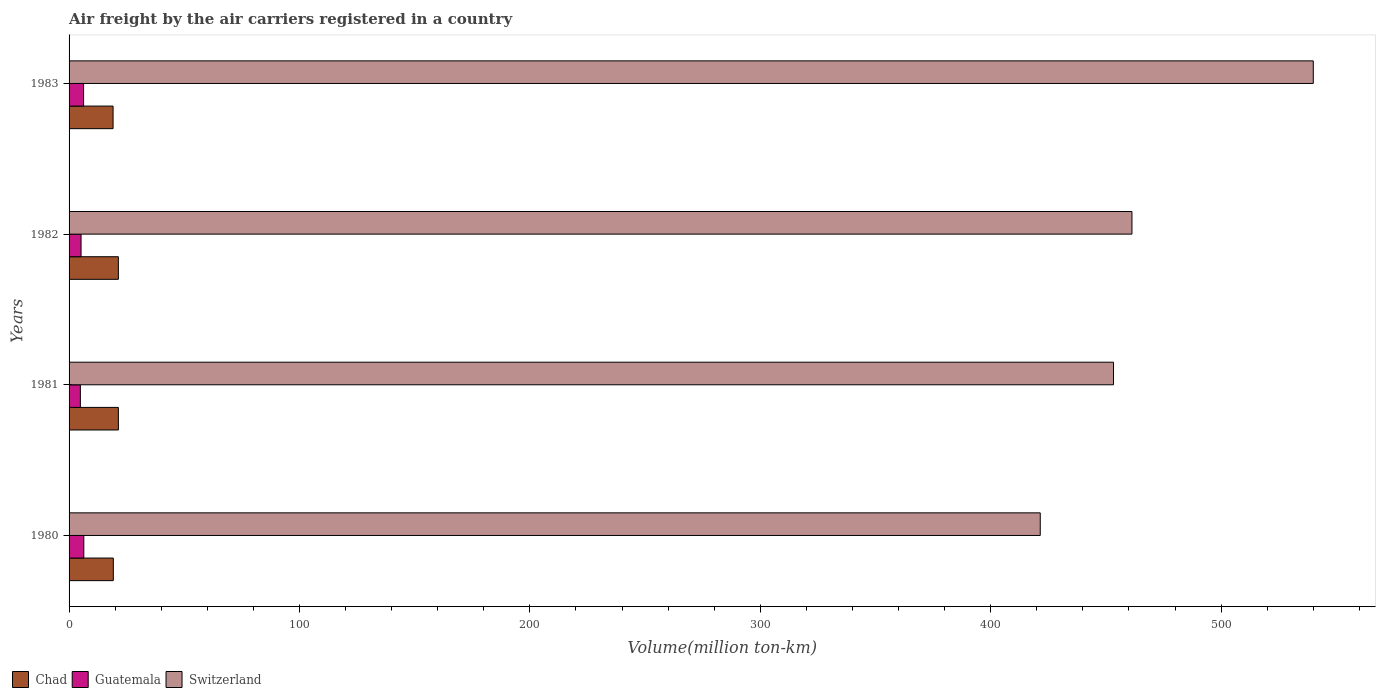How many different coloured bars are there?
Your response must be concise. 3. How many groups of bars are there?
Provide a succinct answer. 4. Are the number of bars per tick equal to the number of legend labels?
Ensure brevity in your answer.  Yes. Are the number of bars on each tick of the Y-axis equal?
Offer a terse response. Yes. How many bars are there on the 1st tick from the bottom?
Provide a short and direct response. 3. What is the volume of the air carriers in Switzerland in 1983?
Keep it short and to the point. 540. Across all years, what is the maximum volume of the air carriers in Chad?
Offer a very short reply. 21.4. Across all years, what is the minimum volume of the air carriers in Guatemala?
Give a very brief answer. 4.9. In which year was the volume of the air carriers in Switzerland maximum?
Provide a short and direct response. 1983. In which year was the volume of the air carriers in Switzerland minimum?
Your answer should be very brief. 1980. What is the total volume of the air carriers in Switzerland in the graph?
Provide a succinct answer. 1876.1. What is the difference between the volume of the air carriers in Chad in 1980 and that in 1982?
Your answer should be very brief. -2.2. What is the difference between the volume of the air carriers in Switzerland in 1981 and the volume of the air carriers in Guatemala in 1983?
Offer a very short reply. 447. What is the average volume of the air carriers in Guatemala per year?
Keep it short and to the point. 5.7. In the year 1981, what is the difference between the volume of the air carriers in Chad and volume of the air carriers in Switzerland?
Ensure brevity in your answer.  -431.9. What is the ratio of the volume of the air carriers in Chad in 1982 to that in 1983?
Make the answer very short. 1.12. Is the difference between the volume of the air carriers in Chad in 1980 and 1982 greater than the difference between the volume of the air carriers in Switzerland in 1980 and 1982?
Keep it short and to the point. Yes. What is the difference between the highest and the lowest volume of the air carriers in Chad?
Your answer should be very brief. 2.3. In how many years, is the volume of the air carriers in Guatemala greater than the average volume of the air carriers in Guatemala taken over all years?
Give a very brief answer. 2. What does the 1st bar from the top in 1981 represents?
Provide a short and direct response. Switzerland. What does the 2nd bar from the bottom in 1980 represents?
Keep it short and to the point. Guatemala. How many bars are there?
Provide a short and direct response. 12. Are the values on the major ticks of X-axis written in scientific E-notation?
Your answer should be compact. No. Does the graph contain any zero values?
Ensure brevity in your answer.  No. Where does the legend appear in the graph?
Provide a succinct answer. Bottom left. What is the title of the graph?
Give a very brief answer. Air freight by the air carriers registered in a country. Does "Libya" appear as one of the legend labels in the graph?
Provide a short and direct response. No. What is the label or title of the X-axis?
Provide a succinct answer. Volume(million ton-km). What is the label or title of the Y-axis?
Give a very brief answer. Years. What is the Volume(million ton-km) of Chad in 1980?
Your response must be concise. 19.2. What is the Volume(million ton-km) of Guatemala in 1980?
Keep it short and to the point. 6.4. What is the Volume(million ton-km) of Switzerland in 1980?
Offer a terse response. 421.5. What is the Volume(million ton-km) in Chad in 1981?
Your response must be concise. 21.4. What is the Volume(million ton-km) in Guatemala in 1981?
Your answer should be compact. 4.9. What is the Volume(million ton-km) of Switzerland in 1981?
Provide a succinct answer. 453.3. What is the Volume(million ton-km) in Chad in 1982?
Provide a short and direct response. 21.4. What is the Volume(million ton-km) of Guatemala in 1982?
Keep it short and to the point. 5.2. What is the Volume(million ton-km) of Switzerland in 1982?
Keep it short and to the point. 461.3. What is the Volume(million ton-km) in Chad in 1983?
Keep it short and to the point. 19.1. What is the Volume(million ton-km) in Guatemala in 1983?
Ensure brevity in your answer.  6.3. What is the Volume(million ton-km) of Switzerland in 1983?
Provide a succinct answer. 540. Across all years, what is the maximum Volume(million ton-km) of Chad?
Ensure brevity in your answer.  21.4. Across all years, what is the maximum Volume(million ton-km) of Guatemala?
Your response must be concise. 6.4. Across all years, what is the maximum Volume(million ton-km) of Switzerland?
Your answer should be very brief. 540. Across all years, what is the minimum Volume(million ton-km) of Chad?
Offer a terse response. 19.1. Across all years, what is the minimum Volume(million ton-km) of Guatemala?
Keep it short and to the point. 4.9. Across all years, what is the minimum Volume(million ton-km) of Switzerland?
Offer a terse response. 421.5. What is the total Volume(million ton-km) of Chad in the graph?
Make the answer very short. 81.1. What is the total Volume(million ton-km) in Guatemala in the graph?
Your answer should be very brief. 22.8. What is the total Volume(million ton-km) in Switzerland in the graph?
Make the answer very short. 1876.1. What is the difference between the Volume(million ton-km) of Guatemala in 1980 and that in 1981?
Offer a terse response. 1.5. What is the difference between the Volume(million ton-km) of Switzerland in 1980 and that in 1981?
Keep it short and to the point. -31.8. What is the difference between the Volume(million ton-km) in Chad in 1980 and that in 1982?
Provide a succinct answer. -2.2. What is the difference between the Volume(million ton-km) in Guatemala in 1980 and that in 1982?
Make the answer very short. 1.2. What is the difference between the Volume(million ton-km) in Switzerland in 1980 and that in 1982?
Provide a succinct answer. -39.8. What is the difference between the Volume(million ton-km) in Guatemala in 1980 and that in 1983?
Offer a terse response. 0.1. What is the difference between the Volume(million ton-km) of Switzerland in 1980 and that in 1983?
Offer a terse response. -118.5. What is the difference between the Volume(million ton-km) of Chad in 1981 and that in 1982?
Your response must be concise. 0. What is the difference between the Volume(million ton-km) in Guatemala in 1981 and that in 1982?
Your response must be concise. -0.3. What is the difference between the Volume(million ton-km) of Switzerland in 1981 and that in 1982?
Give a very brief answer. -8. What is the difference between the Volume(million ton-km) in Chad in 1981 and that in 1983?
Offer a very short reply. 2.3. What is the difference between the Volume(million ton-km) in Guatemala in 1981 and that in 1983?
Keep it short and to the point. -1.4. What is the difference between the Volume(million ton-km) of Switzerland in 1981 and that in 1983?
Your answer should be compact. -86.7. What is the difference between the Volume(million ton-km) in Switzerland in 1982 and that in 1983?
Give a very brief answer. -78.7. What is the difference between the Volume(million ton-km) of Chad in 1980 and the Volume(million ton-km) of Switzerland in 1981?
Make the answer very short. -434.1. What is the difference between the Volume(million ton-km) of Guatemala in 1980 and the Volume(million ton-km) of Switzerland in 1981?
Provide a short and direct response. -446.9. What is the difference between the Volume(million ton-km) in Chad in 1980 and the Volume(million ton-km) in Switzerland in 1982?
Offer a terse response. -442.1. What is the difference between the Volume(million ton-km) in Guatemala in 1980 and the Volume(million ton-km) in Switzerland in 1982?
Your response must be concise. -454.9. What is the difference between the Volume(million ton-km) in Chad in 1980 and the Volume(million ton-km) in Switzerland in 1983?
Give a very brief answer. -520.8. What is the difference between the Volume(million ton-km) in Guatemala in 1980 and the Volume(million ton-km) in Switzerland in 1983?
Offer a very short reply. -533.6. What is the difference between the Volume(million ton-km) of Chad in 1981 and the Volume(million ton-km) of Switzerland in 1982?
Make the answer very short. -439.9. What is the difference between the Volume(million ton-km) in Guatemala in 1981 and the Volume(million ton-km) in Switzerland in 1982?
Ensure brevity in your answer.  -456.4. What is the difference between the Volume(million ton-km) in Chad in 1981 and the Volume(million ton-km) in Guatemala in 1983?
Make the answer very short. 15.1. What is the difference between the Volume(million ton-km) of Chad in 1981 and the Volume(million ton-km) of Switzerland in 1983?
Your answer should be compact. -518.6. What is the difference between the Volume(million ton-km) of Guatemala in 1981 and the Volume(million ton-km) of Switzerland in 1983?
Your response must be concise. -535.1. What is the difference between the Volume(million ton-km) of Chad in 1982 and the Volume(million ton-km) of Guatemala in 1983?
Provide a short and direct response. 15.1. What is the difference between the Volume(million ton-km) in Chad in 1982 and the Volume(million ton-km) in Switzerland in 1983?
Your answer should be compact. -518.6. What is the difference between the Volume(million ton-km) in Guatemala in 1982 and the Volume(million ton-km) in Switzerland in 1983?
Provide a short and direct response. -534.8. What is the average Volume(million ton-km) in Chad per year?
Offer a terse response. 20.27. What is the average Volume(million ton-km) of Guatemala per year?
Offer a very short reply. 5.7. What is the average Volume(million ton-km) in Switzerland per year?
Make the answer very short. 469.02. In the year 1980, what is the difference between the Volume(million ton-km) of Chad and Volume(million ton-km) of Guatemala?
Your response must be concise. 12.8. In the year 1980, what is the difference between the Volume(million ton-km) in Chad and Volume(million ton-km) in Switzerland?
Your response must be concise. -402.3. In the year 1980, what is the difference between the Volume(million ton-km) of Guatemala and Volume(million ton-km) of Switzerland?
Provide a succinct answer. -415.1. In the year 1981, what is the difference between the Volume(million ton-km) of Chad and Volume(million ton-km) of Guatemala?
Ensure brevity in your answer.  16.5. In the year 1981, what is the difference between the Volume(million ton-km) in Chad and Volume(million ton-km) in Switzerland?
Make the answer very short. -431.9. In the year 1981, what is the difference between the Volume(million ton-km) in Guatemala and Volume(million ton-km) in Switzerland?
Offer a terse response. -448.4. In the year 1982, what is the difference between the Volume(million ton-km) in Chad and Volume(million ton-km) in Switzerland?
Offer a terse response. -439.9. In the year 1982, what is the difference between the Volume(million ton-km) in Guatemala and Volume(million ton-km) in Switzerland?
Keep it short and to the point. -456.1. In the year 1983, what is the difference between the Volume(million ton-km) in Chad and Volume(million ton-km) in Switzerland?
Provide a short and direct response. -520.9. In the year 1983, what is the difference between the Volume(million ton-km) in Guatemala and Volume(million ton-km) in Switzerland?
Your response must be concise. -533.7. What is the ratio of the Volume(million ton-km) in Chad in 1980 to that in 1981?
Make the answer very short. 0.9. What is the ratio of the Volume(million ton-km) of Guatemala in 1980 to that in 1981?
Your answer should be compact. 1.31. What is the ratio of the Volume(million ton-km) of Switzerland in 1980 to that in 1981?
Provide a short and direct response. 0.93. What is the ratio of the Volume(million ton-km) of Chad in 1980 to that in 1982?
Offer a terse response. 0.9. What is the ratio of the Volume(million ton-km) in Guatemala in 1980 to that in 1982?
Make the answer very short. 1.23. What is the ratio of the Volume(million ton-km) in Switzerland in 1980 to that in 1982?
Your answer should be very brief. 0.91. What is the ratio of the Volume(million ton-km) of Guatemala in 1980 to that in 1983?
Keep it short and to the point. 1.02. What is the ratio of the Volume(million ton-km) in Switzerland in 1980 to that in 1983?
Provide a succinct answer. 0.78. What is the ratio of the Volume(million ton-km) in Guatemala in 1981 to that in 1982?
Provide a short and direct response. 0.94. What is the ratio of the Volume(million ton-km) in Switzerland in 1981 to that in 1982?
Offer a very short reply. 0.98. What is the ratio of the Volume(million ton-km) of Chad in 1981 to that in 1983?
Offer a terse response. 1.12. What is the ratio of the Volume(million ton-km) of Switzerland in 1981 to that in 1983?
Offer a terse response. 0.84. What is the ratio of the Volume(million ton-km) in Chad in 1982 to that in 1983?
Make the answer very short. 1.12. What is the ratio of the Volume(million ton-km) in Guatemala in 1982 to that in 1983?
Provide a succinct answer. 0.83. What is the ratio of the Volume(million ton-km) of Switzerland in 1982 to that in 1983?
Your answer should be compact. 0.85. What is the difference between the highest and the second highest Volume(million ton-km) of Chad?
Your response must be concise. 0. What is the difference between the highest and the second highest Volume(million ton-km) in Switzerland?
Make the answer very short. 78.7. What is the difference between the highest and the lowest Volume(million ton-km) of Chad?
Make the answer very short. 2.3. What is the difference between the highest and the lowest Volume(million ton-km) of Switzerland?
Make the answer very short. 118.5. 